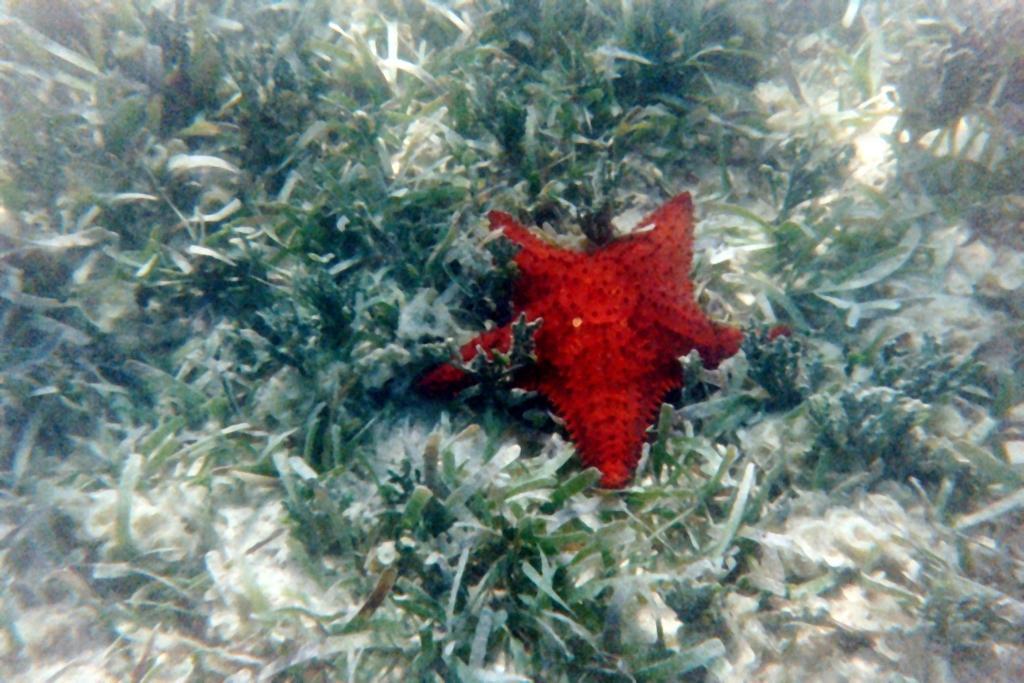Could you give a brief overview of what you see in this image? In this image we can see a star fish and aquatic plants. 